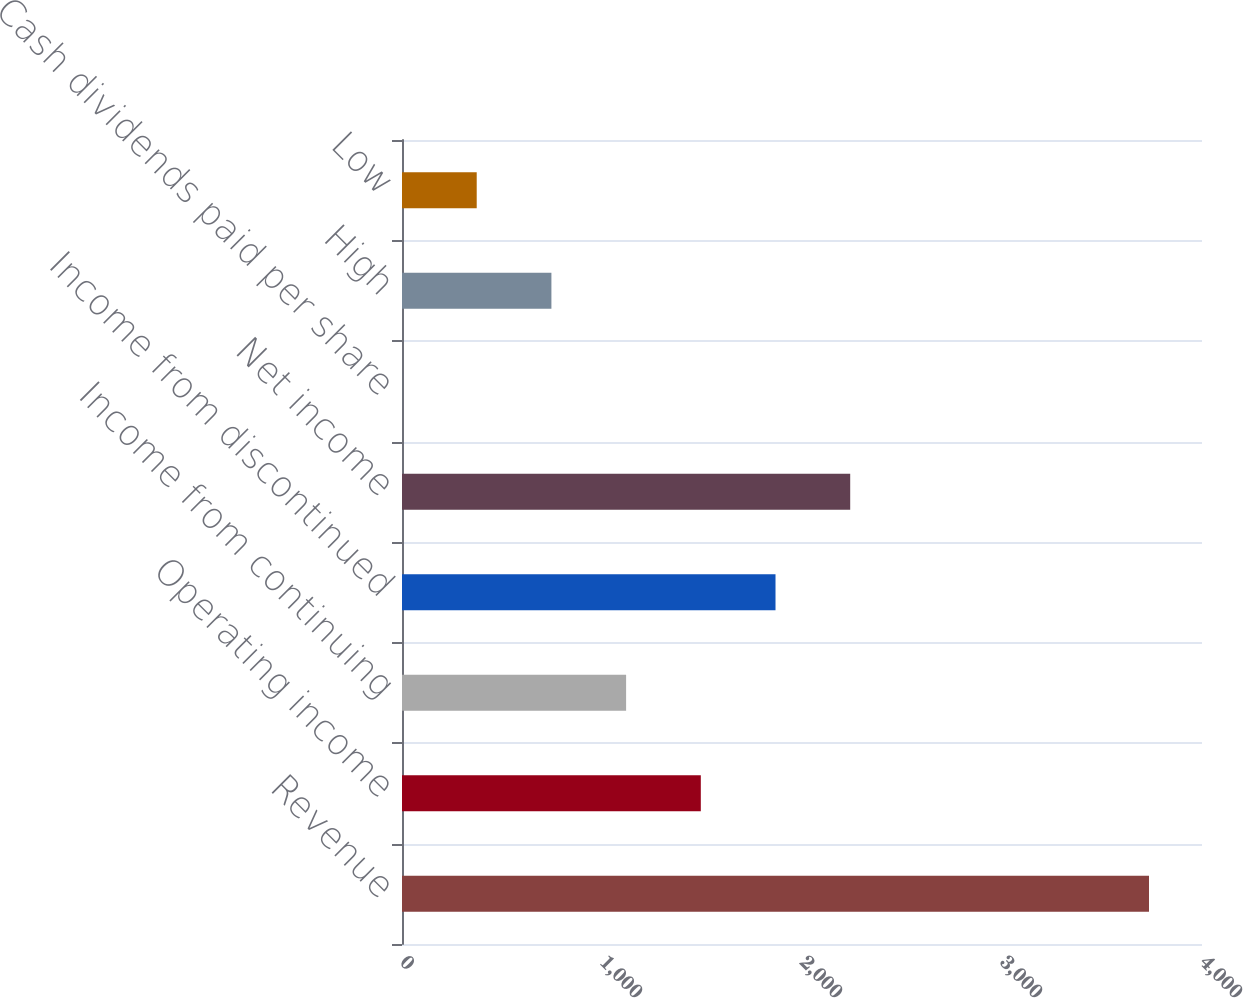Convert chart to OTSL. <chart><loc_0><loc_0><loc_500><loc_500><bar_chart><fcel>Revenue<fcel>Operating income<fcel>Income from continuing<fcel>Income from discontinued<fcel>Net income<fcel>Cash dividends paid per share<fcel>High<fcel>Low<nl><fcel>3735<fcel>1494.05<fcel>1120.56<fcel>1867.54<fcel>2241.03<fcel>0.09<fcel>747.07<fcel>373.58<nl></chart> 